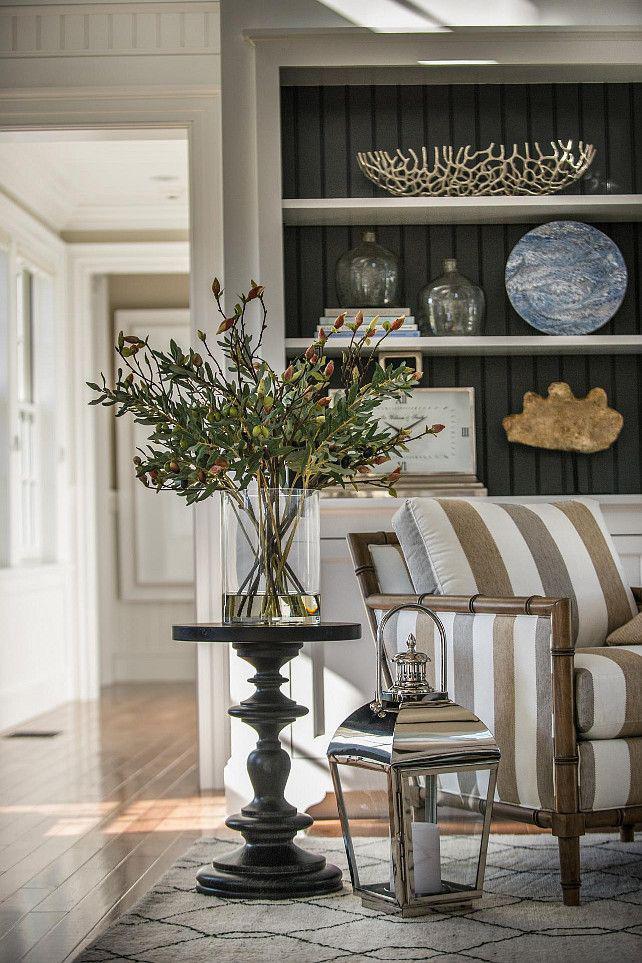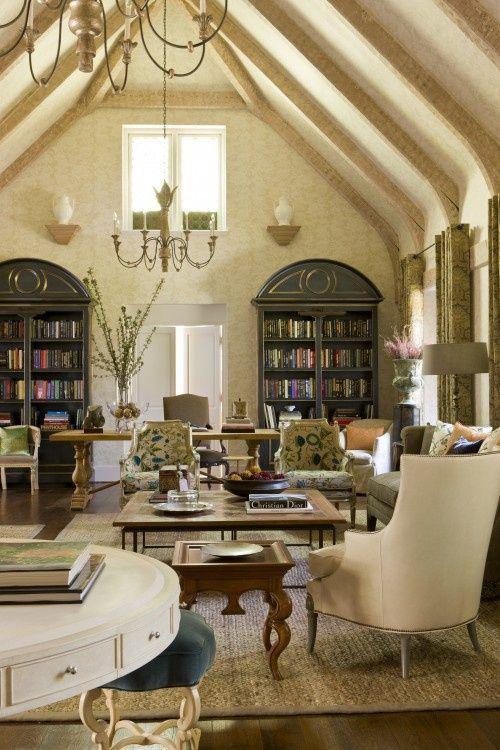The first image is the image on the left, the second image is the image on the right. Given the left and right images, does the statement "One of the ceilings has is angled." hold true? Answer yes or no. Yes. The first image is the image on the left, the second image is the image on the right. Analyze the images presented: Is the assertion "One image shows a room with peaked, beamed ceiling above bookshelves and other furniture." valid? Answer yes or no. Yes. 